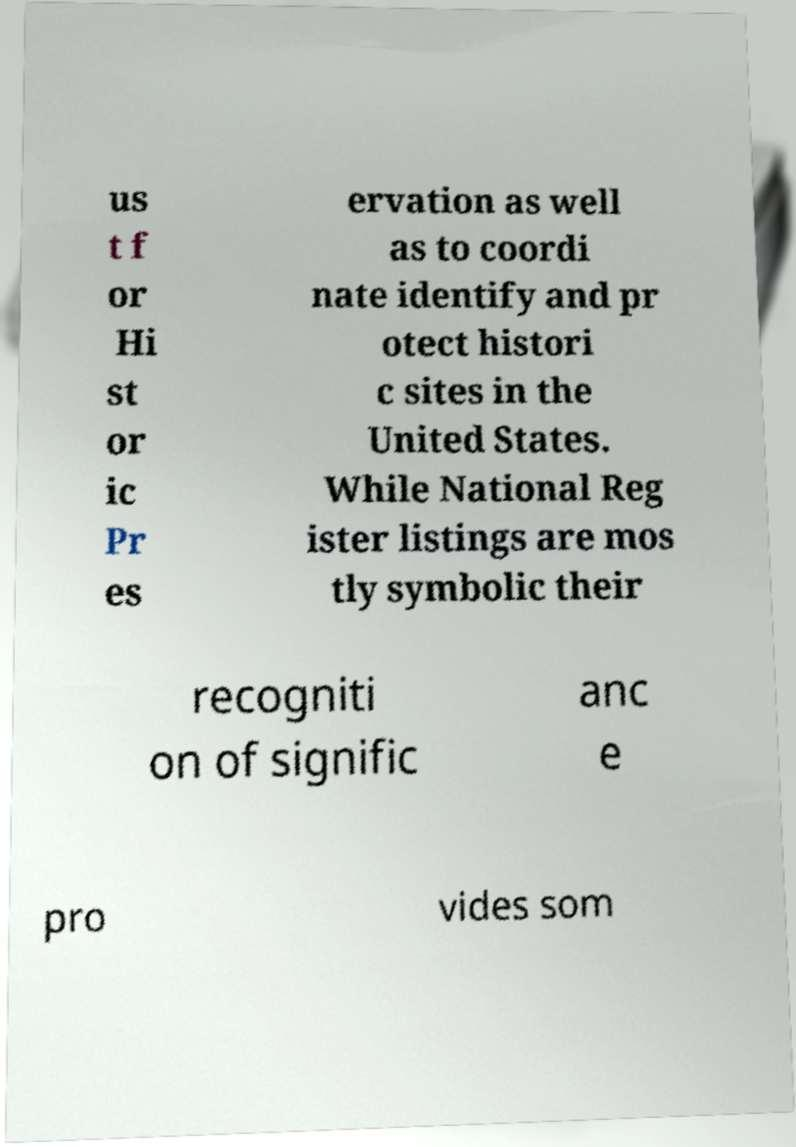Please identify and transcribe the text found in this image. us t f or Hi st or ic Pr es ervation as well as to coordi nate identify and pr otect histori c sites in the United States. While National Reg ister listings are mos tly symbolic their recogniti on of signific anc e pro vides som 